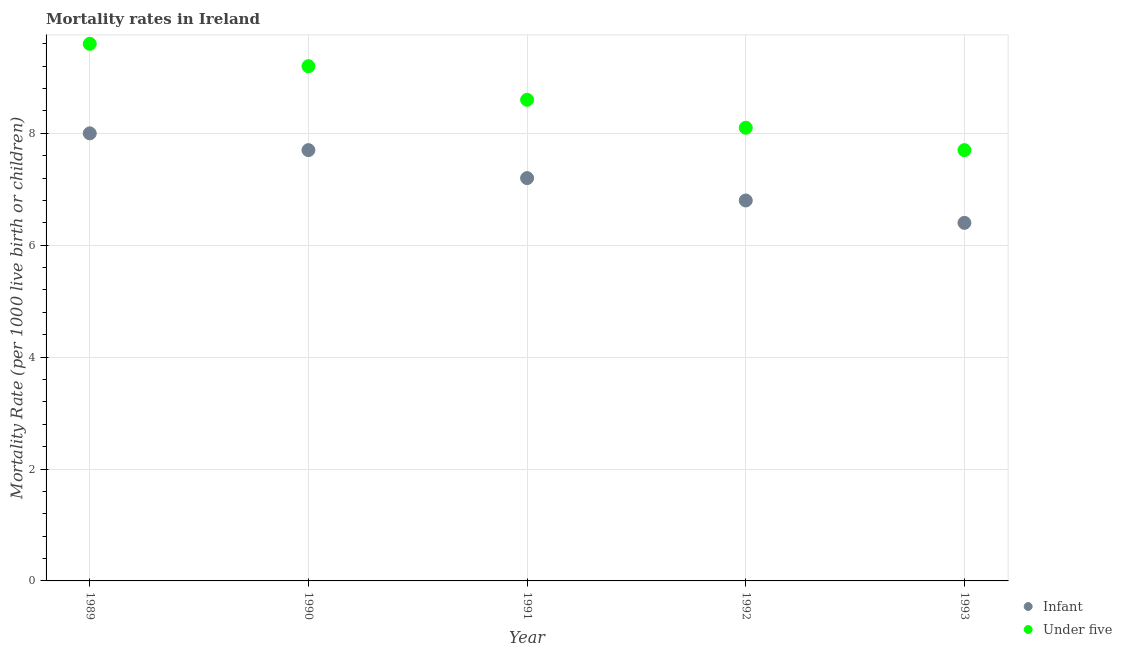Is the number of dotlines equal to the number of legend labels?
Offer a terse response. Yes. What is the infant mortality rate in 1993?
Provide a succinct answer. 6.4. Across all years, what is the maximum under-5 mortality rate?
Give a very brief answer. 9.6. Across all years, what is the minimum under-5 mortality rate?
Your answer should be compact. 7.7. In which year was the infant mortality rate maximum?
Offer a very short reply. 1989. What is the total infant mortality rate in the graph?
Give a very brief answer. 36.1. What is the difference between the under-5 mortality rate in 1989 and that in 1990?
Your answer should be very brief. 0.4. What is the difference between the under-5 mortality rate in 1989 and the infant mortality rate in 1990?
Ensure brevity in your answer.  1.9. What is the average infant mortality rate per year?
Your answer should be compact. 7.22. In the year 1992, what is the difference between the under-5 mortality rate and infant mortality rate?
Make the answer very short. 1.3. What is the ratio of the infant mortality rate in 1990 to that in 1991?
Provide a short and direct response. 1.07. Is the under-5 mortality rate in 1989 less than that in 1992?
Offer a very short reply. No. What is the difference between the highest and the second highest infant mortality rate?
Offer a terse response. 0.3. What is the difference between the highest and the lowest under-5 mortality rate?
Give a very brief answer. 1.9. Is the sum of the under-5 mortality rate in 1989 and 1991 greater than the maximum infant mortality rate across all years?
Keep it short and to the point. Yes. Does the under-5 mortality rate monotonically increase over the years?
Offer a very short reply. No. How many years are there in the graph?
Keep it short and to the point. 5. Are the values on the major ticks of Y-axis written in scientific E-notation?
Provide a short and direct response. No. How many legend labels are there?
Provide a short and direct response. 2. What is the title of the graph?
Keep it short and to the point. Mortality rates in Ireland. Does "Private creditors" appear as one of the legend labels in the graph?
Your answer should be very brief. No. What is the label or title of the Y-axis?
Provide a succinct answer. Mortality Rate (per 1000 live birth or children). What is the Mortality Rate (per 1000 live birth or children) of Under five in 1989?
Provide a short and direct response. 9.6. What is the Mortality Rate (per 1000 live birth or children) in Infant in 1990?
Provide a succinct answer. 7.7. What is the Mortality Rate (per 1000 live birth or children) in Under five in 1992?
Offer a very short reply. 8.1. What is the Mortality Rate (per 1000 live birth or children) in Infant in 1993?
Provide a succinct answer. 6.4. What is the Mortality Rate (per 1000 live birth or children) of Under five in 1993?
Make the answer very short. 7.7. Across all years, what is the maximum Mortality Rate (per 1000 live birth or children) of Infant?
Give a very brief answer. 8. What is the total Mortality Rate (per 1000 live birth or children) of Infant in the graph?
Give a very brief answer. 36.1. What is the total Mortality Rate (per 1000 live birth or children) of Under five in the graph?
Your response must be concise. 43.2. What is the difference between the Mortality Rate (per 1000 live birth or children) of Infant in 1989 and that in 1990?
Your response must be concise. 0.3. What is the difference between the Mortality Rate (per 1000 live birth or children) of Infant in 1989 and that in 1991?
Provide a succinct answer. 0.8. What is the difference between the Mortality Rate (per 1000 live birth or children) in Under five in 1989 and that in 1991?
Offer a very short reply. 1. What is the difference between the Mortality Rate (per 1000 live birth or children) in Infant in 1989 and that in 1992?
Your answer should be compact. 1.2. What is the difference between the Mortality Rate (per 1000 live birth or children) in Under five in 1989 and that in 1992?
Make the answer very short. 1.5. What is the difference between the Mortality Rate (per 1000 live birth or children) in Infant in 1989 and that in 1993?
Provide a succinct answer. 1.6. What is the difference between the Mortality Rate (per 1000 live birth or children) of Infant in 1990 and that in 1991?
Ensure brevity in your answer.  0.5. What is the difference between the Mortality Rate (per 1000 live birth or children) in Under five in 1990 and that in 1991?
Your answer should be compact. 0.6. What is the difference between the Mortality Rate (per 1000 live birth or children) of Infant in 1990 and that in 1993?
Your response must be concise. 1.3. What is the difference between the Mortality Rate (per 1000 live birth or children) of Infant in 1991 and that in 1992?
Keep it short and to the point. 0.4. What is the difference between the Mortality Rate (per 1000 live birth or children) of Under five in 1992 and that in 1993?
Offer a terse response. 0.4. What is the difference between the Mortality Rate (per 1000 live birth or children) of Infant in 1989 and the Mortality Rate (per 1000 live birth or children) of Under five in 1992?
Your answer should be compact. -0.1. What is the difference between the Mortality Rate (per 1000 live birth or children) in Infant in 1989 and the Mortality Rate (per 1000 live birth or children) in Under five in 1993?
Provide a short and direct response. 0.3. What is the difference between the Mortality Rate (per 1000 live birth or children) of Infant in 1990 and the Mortality Rate (per 1000 live birth or children) of Under five in 1991?
Your answer should be very brief. -0.9. What is the difference between the Mortality Rate (per 1000 live birth or children) of Infant in 1990 and the Mortality Rate (per 1000 live birth or children) of Under five in 1992?
Your answer should be compact. -0.4. What is the difference between the Mortality Rate (per 1000 live birth or children) in Infant in 1990 and the Mortality Rate (per 1000 live birth or children) in Under five in 1993?
Provide a succinct answer. 0. What is the difference between the Mortality Rate (per 1000 live birth or children) of Infant in 1992 and the Mortality Rate (per 1000 live birth or children) of Under five in 1993?
Make the answer very short. -0.9. What is the average Mortality Rate (per 1000 live birth or children) of Infant per year?
Ensure brevity in your answer.  7.22. What is the average Mortality Rate (per 1000 live birth or children) of Under five per year?
Offer a very short reply. 8.64. In the year 1991, what is the difference between the Mortality Rate (per 1000 live birth or children) in Infant and Mortality Rate (per 1000 live birth or children) in Under five?
Your answer should be compact. -1.4. What is the ratio of the Mortality Rate (per 1000 live birth or children) of Infant in 1989 to that in 1990?
Provide a succinct answer. 1.04. What is the ratio of the Mortality Rate (per 1000 live birth or children) in Under five in 1989 to that in 1990?
Provide a short and direct response. 1.04. What is the ratio of the Mortality Rate (per 1000 live birth or children) in Under five in 1989 to that in 1991?
Give a very brief answer. 1.12. What is the ratio of the Mortality Rate (per 1000 live birth or children) of Infant in 1989 to that in 1992?
Provide a succinct answer. 1.18. What is the ratio of the Mortality Rate (per 1000 live birth or children) of Under five in 1989 to that in 1992?
Provide a succinct answer. 1.19. What is the ratio of the Mortality Rate (per 1000 live birth or children) of Infant in 1989 to that in 1993?
Offer a very short reply. 1.25. What is the ratio of the Mortality Rate (per 1000 live birth or children) in Under five in 1989 to that in 1993?
Your answer should be very brief. 1.25. What is the ratio of the Mortality Rate (per 1000 live birth or children) in Infant in 1990 to that in 1991?
Your response must be concise. 1.07. What is the ratio of the Mortality Rate (per 1000 live birth or children) of Under five in 1990 to that in 1991?
Offer a terse response. 1.07. What is the ratio of the Mortality Rate (per 1000 live birth or children) in Infant in 1990 to that in 1992?
Your response must be concise. 1.13. What is the ratio of the Mortality Rate (per 1000 live birth or children) in Under five in 1990 to that in 1992?
Offer a terse response. 1.14. What is the ratio of the Mortality Rate (per 1000 live birth or children) in Infant in 1990 to that in 1993?
Your answer should be very brief. 1.2. What is the ratio of the Mortality Rate (per 1000 live birth or children) of Under five in 1990 to that in 1993?
Your answer should be compact. 1.19. What is the ratio of the Mortality Rate (per 1000 live birth or children) of Infant in 1991 to that in 1992?
Provide a succinct answer. 1.06. What is the ratio of the Mortality Rate (per 1000 live birth or children) of Under five in 1991 to that in 1992?
Give a very brief answer. 1.06. What is the ratio of the Mortality Rate (per 1000 live birth or children) in Infant in 1991 to that in 1993?
Your response must be concise. 1.12. What is the ratio of the Mortality Rate (per 1000 live birth or children) in Under five in 1991 to that in 1993?
Your response must be concise. 1.12. What is the ratio of the Mortality Rate (per 1000 live birth or children) of Infant in 1992 to that in 1993?
Ensure brevity in your answer.  1.06. What is the ratio of the Mortality Rate (per 1000 live birth or children) in Under five in 1992 to that in 1993?
Provide a short and direct response. 1.05. What is the difference between the highest and the second highest Mortality Rate (per 1000 live birth or children) of Infant?
Give a very brief answer. 0.3. What is the difference between the highest and the second highest Mortality Rate (per 1000 live birth or children) in Under five?
Your answer should be very brief. 0.4. What is the difference between the highest and the lowest Mortality Rate (per 1000 live birth or children) in Under five?
Offer a terse response. 1.9. 